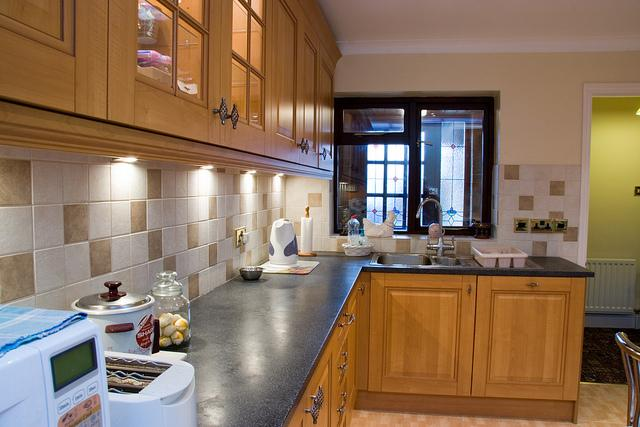What appliance is next to the microwave? Please explain your reasoning. toaster. You can see the slots where bread goes in on this object and it looks just like a toaster. 